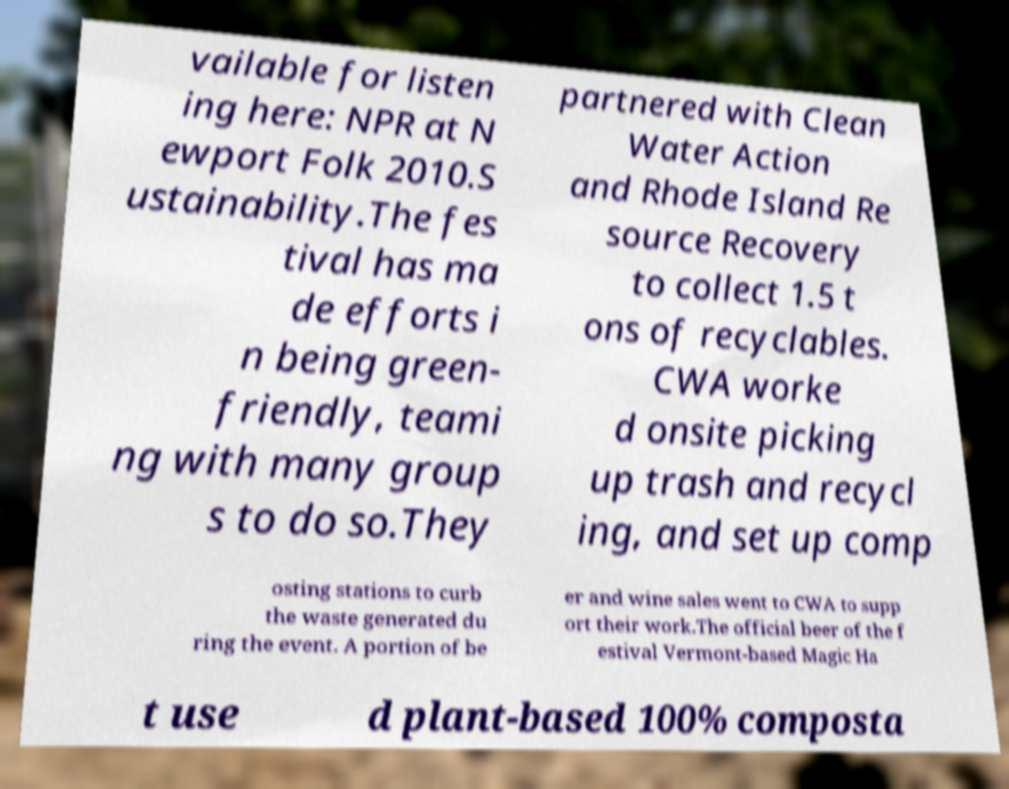Can you read and provide the text displayed in the image?This photo seems to have some interesting text. Can you extract and type it out for me? vailable for listen ing here: NPR at N ewport Folk 2010.S ustainability.The fes tival has ma de efforts i n being green- friendly, teami ng with many group s to do so.They partnered with Clean Water Action and Rhode Island Re source Recovery to collect 1.5 t ons of recyclables. CWA worke d onsite picking up trash and recycl ing, and set up comp osting stations to curb the waste generated du ring the event. A portion of be er and wine sales went to CWA to supp ort their work.The official beer of the f estival Vermont-based Magic Ha t use d plant-based 100% composta 